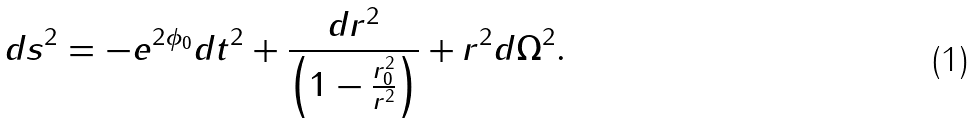<formula> <loc_0><loc_0><loc_500><loc_500>d s ^ { 2 } = - e ^ { 2 \phi _ { 0 } } d t ^ { 2 } + \frac { d r ^ { 2 } } { \left ( 1 - \frac { r _ { 0 } ^ { 2 } } { r ^ { 2 } } \right ) } + r ^ { 2 } d \Omega ^ { 2 } .</formula> 